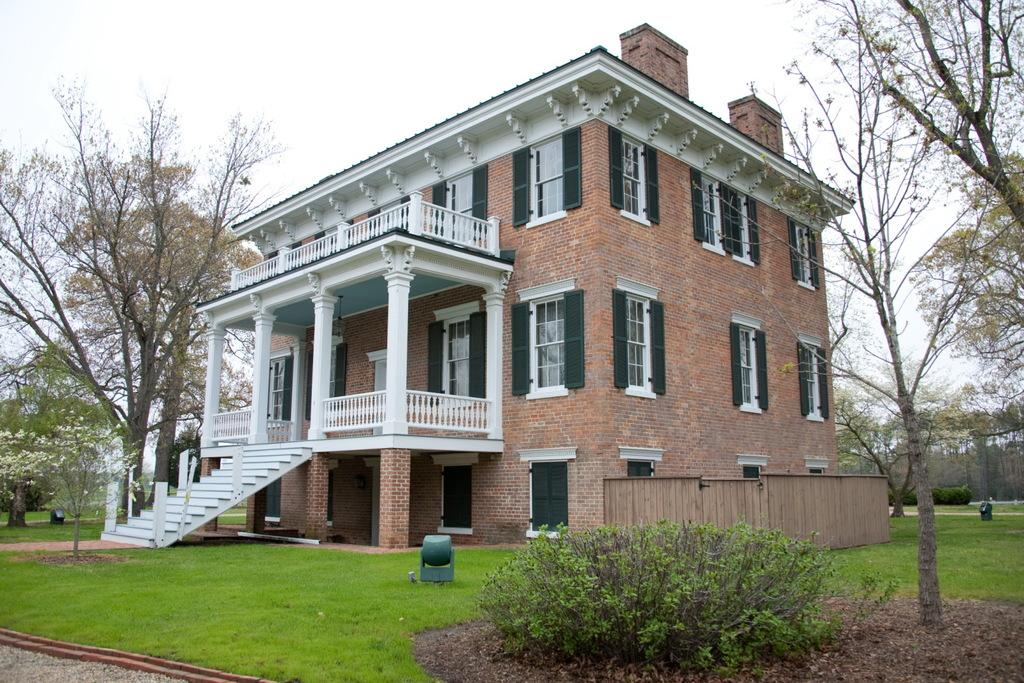What type of structure is visible in the picture? There is a house in the picture. What type of vegetation can be seen in the picture? There is grass and plants visible in the picture. What is in the background of the picture? There are trees in the background of the picture. How would you describe the sky in the picture? The sky is cloudy at the top of the picture. What type of oatmeal is being served on the porch of the house in the picture? There is no oatmeal visible in the picture; it only shows a house, grass, plants, trees, and a cloudy sky. 